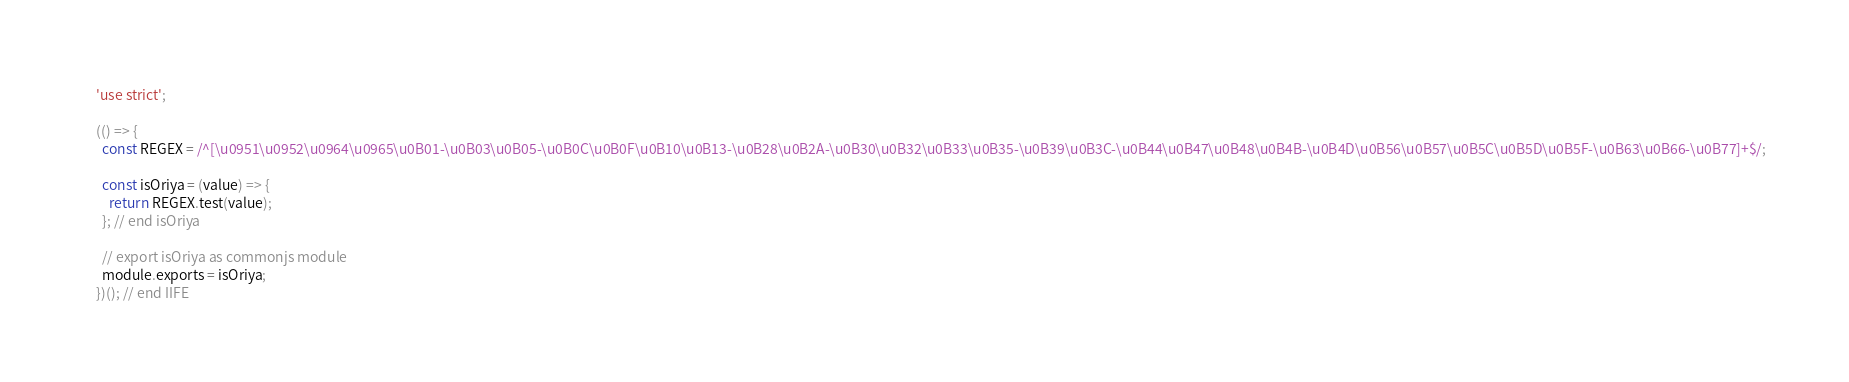<code> <loc_0><loc_0><loc_500><loc_500><_JavaScript_>'use strict';

(() => {
  const REGEX = /^[\u0951\u0952\u0964\u0965\u0B01-\u0B03\u0B05-\u0B0C\u0B0F\u0B10\u0B13-\u0B28\u0B2A-\u0B30\u0B32\u0B33\u0B35-\u0B39\u0B3C-\u0B44\u0B47\u0B48\u0B4B-\u0B4D\u0B56\u0B57\u0B5C\u0B5D\u0B5F-\u0B63\u0B66-\u0B77]+$/;

  const isOriya = (value) => {
    return REGEX.test(value);
  }; // end isOriya

  // export isOriya as commonjs module
  module.exports = isOriya;
})(); // end IIFE</code> 